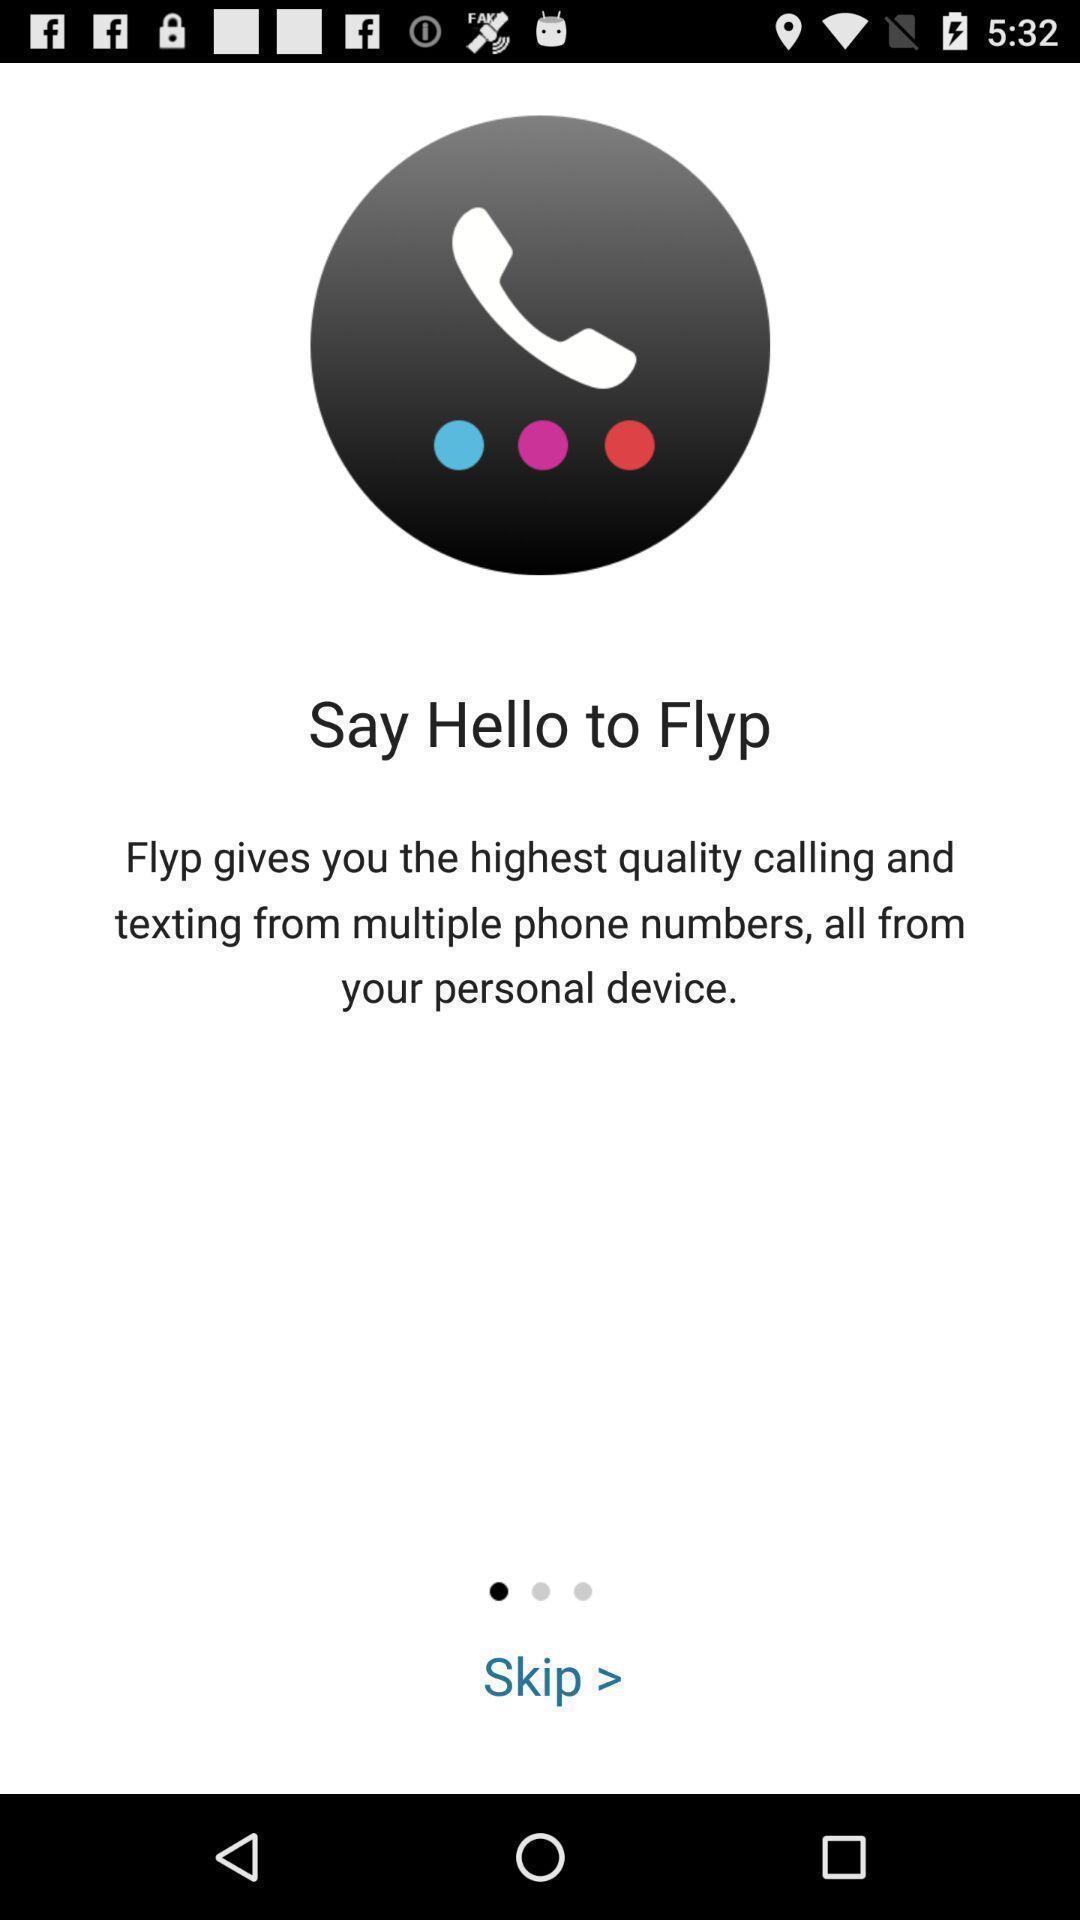What is the overall content of this screenshot? Welcome page. 